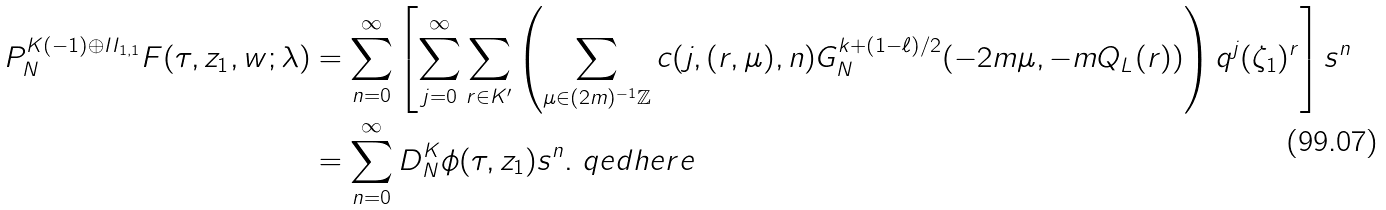<formula> <loc_0><loc_0><loc_500><loc_500>P _ { N } ^ { K ( - 1 ) \oplus I I _ { 1 , 1 } } F ( \tau , z _ { 1 } , w ; \lambda ) & = \sum _ { n = 0 } ^ { \infty } \left [ \sum _ { j = 0 } ^ { \infty } \sum _ { r \in K ^ { \prime } } \left ( \sum _ { \mu \in ( 2 m ) ^ { - 1 } \mathbb { Z } } c ( j , ( r , \mu ) , n ) G _ { N } ^ { k + ( 1 - \ell ) / 2 } ( - 2 m \mu , - m Q _ { L } ( r ) ) \right ) q ^ { j } ( \zeta _ { 1 } ) ^ { r } \right ] s ^ { n } \\ & = \sum _ { n = 0 } ^ { \infty } D _ { N } ^ { K } \phi ( \tau , z _ { 1 } ) s ^ { n } . \ q e d h e r e</formula> 